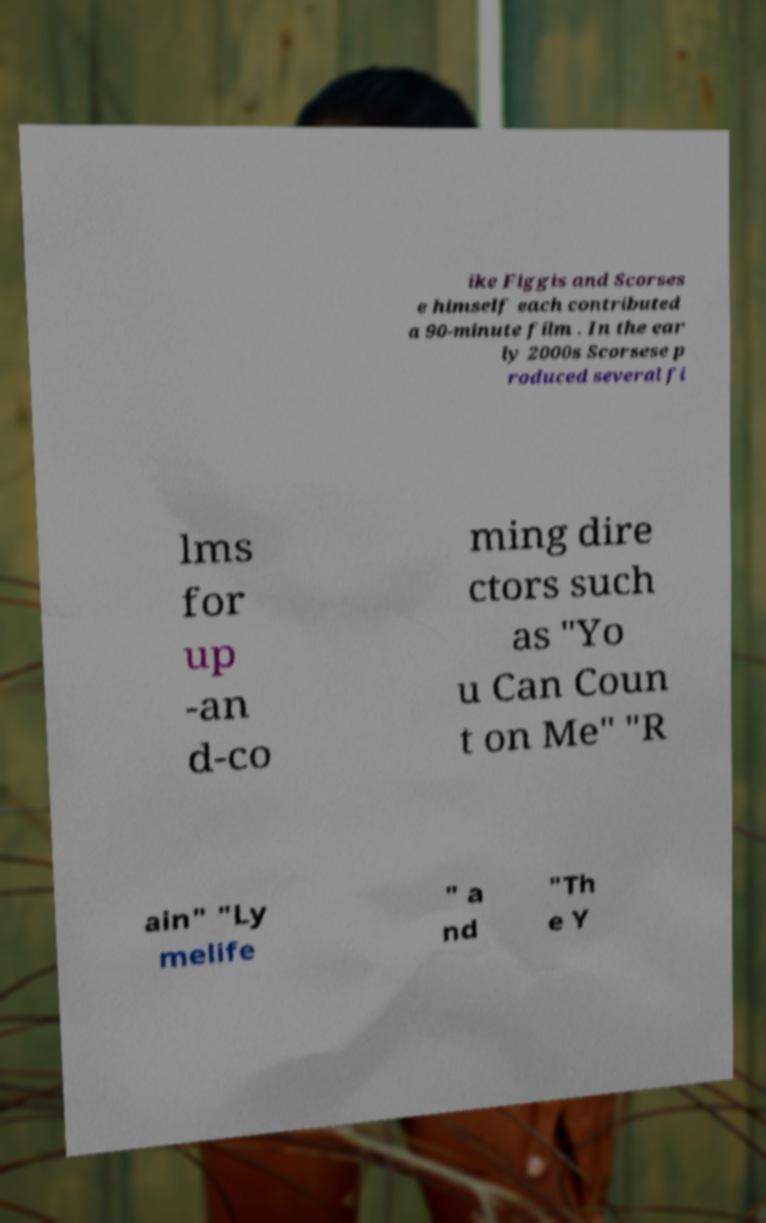For documentation purposes, I need the text within this image transcribed. Could you provide that? ike Figgis and Scorses e himself each contributed a 90-minute film . In the ear ly 2000s Scorsese p roduced several fi lms for up -an d-co ming dire ctors such as "Yo u Can Coun t on Me" "R ain" "Ly melife " a nd "Th e Y 